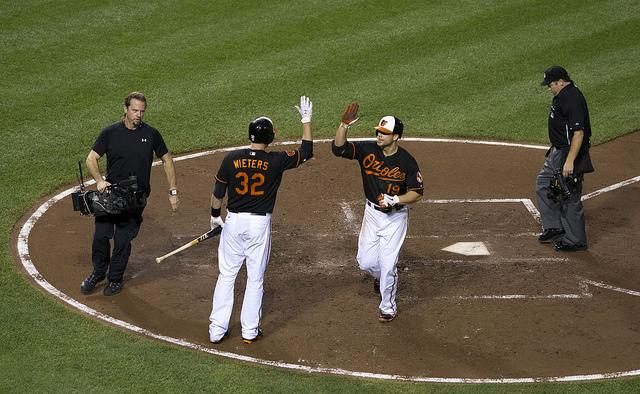What category of animal is their mascot in? bird 